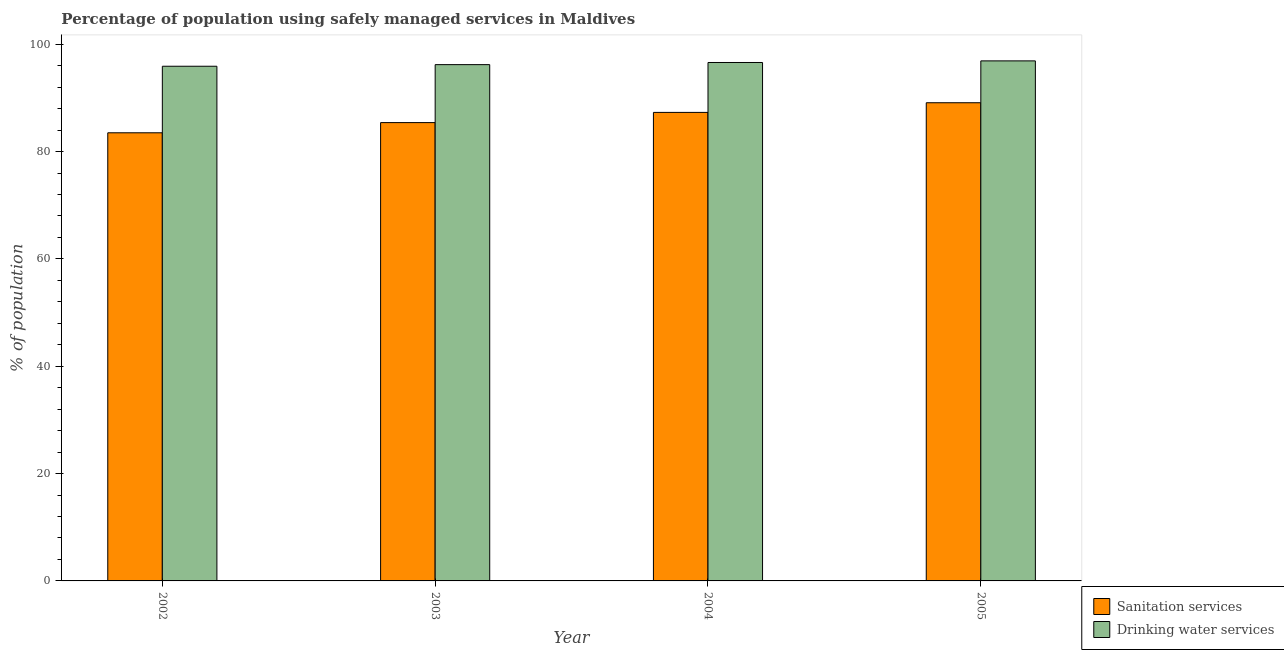How many different coloured bars are there?
Offer a very short reply. 2. Are the number of bars per tick equal to the number of legend labels?
Keep it short and to the point. Yes. Are the number of bars on each tick of the X-axis equal?
Offer a terse response. Yes. What is the label of the 2nd group of bars from the left?
Offer a very short reply. 2003. What is the percentage of population who used drinking water services in 2004?
Your response must be concise. 96.6. Across all years, what is the maximum percentage of population who used drinking water services?
Provide a succinct answer. 96.9. Across all years, what is the minimum percentage of population who used sanitation services?
Make the answer very short. 83.5. What is the total percentage of population who used drinking water services in the graph?
Make the answer very short. 385.6. What is the difference between the percentage of population who used drinking water services in 2003 and that in 2005?
Keep it short and to the point. -0.7. What is the difference between the percentage of population who used sanitation services in 2005 and the percentage of population who used drinking water services in 2002?
Keep it short and to the point. 5.6. What is the average percentage of population who used sanitation services per year?
Offer a terse response. 86.32. In the year 2005, what is the difference between the percentage of population who used sanitation services and percentage of population who used drinking water services?
Give a very brief answer. 0. In how many years, is the percentage of population who used drinking water services greater than 24 %?
Give a very brief answer. 4. What is the ratio of the percentage of population who used drinking water services in 2003 to that in 2005?
Keep it short and to the point. 0.99. Is the percentage of population who used drinking water services in 2003 less than that in 2005?
Give a very brief answer. Yes. What is the difference between the highest and the second highest percentage of population who used sanitation services?
Provide a short and direct response. 1.8. What is the difference between the highest and the lowest percentage of population who used sanitation services?
Give a very brief answer. 5.6. In how many years, is the percentage of population who used drinking water services greater than the average percentage of population who used drinking water services taken over all years?
Keep it short and to the point. 2. Is the sum of the percentage of population who used sanitation services in 2003 and 2004 greater than the maximum percentage of population who used drinking water services across all years?
Make the answer very short. Yes. What does the 1st bar from the left in 2005 represents?
Your answer should be compact. Sanitation services. What does the 2nd bar from the right in 2003 represents?
Make the answer very short. Sanitation services. Are all the bars in the graph horizontal?
Give a very brief answer. No. What is the difference between two consecutive major ticks on the Y-axis?
Provide a succinct answer. 20. What is the title of the graph?
Offer a terse response. Percentage of population using safely managed services in Maldives. Does "Travel services" appear as one of the legend labels in the graph?
Your answer should be compact. No. What is the label or title of the X-axis?
Offer a very short reply. Year. What is the label or title of the Y-axis?
Make the answer very short. % of population. What is the % of population in Sanitation services in 2002?
Your response must be concise. 83.5. What is the % of population in Drinking water services in 2002?
Provide a succinct answer. 95.9. What is the % of population in Sanitation services in 2003?
Give a very brief answer. 85.4. What is the % of population in Drinking water services in 2003?
Provide a short and direct response. 96.2. What is the % of population in Sanitation services in 2004?
Offer a terse response. 87.3. What is the % of population of Drinking water services in 2004?
Give a very brief answer. 96.6. What is the % of population of Sanitation services in 2005?
Provide a short and direct response. 89.1. What is the % of population in Drinking water services in 2005?
Give a very brief answer. 96.9. Across all years, what is the maximum % of population of Sanitation services?
Your answer should be very brief. 89.1. Across all years, what is the maximum % of population in Drinking water services?
Keep it short and to the point. 96.9. Across all years, what is the minimum % of population in Sanitation services?
Offer a very short reply. 83.5. Across all years, what is the minimum % of population in Drinking water services?
Your answer should be very brief. 95.9. What is the total % of population in Sanitation services in the graph?
Ensure brevity in your answer.  345.3. What is the total % of population in Drinking water services in the graph?
Your response must be concise. 385.6. What is the difference between the % of population of Sanitation services in 2002 and that in 2003?
Keep it short and to the point. -1.9. What is the difference between the % of population in Drinking water services in 2002 and that in 2005?
Your answer should be very brief. -1. What is the difference between the % of population in Drinking water services in 2003 and that in 2004?
Your answer should be very brief. -0.4. What is the difference between the % of population of Drinking water services in 2003 and that in 2005?
Give a very brief answer. -0.7. What is the difference between the % of population in Drinking water services in 2004 and that in 2005?
Your answer should be compact. -0.3. What is the difference between the % of population of Sanitation services in 2004 and the % of population of Drinking water services in 2005?
Your answer should be very brief. -9.6. What is the average % of population in Sanitation services per year?
Your response must be concise. 86.33. What is the average % of population in Drinking water services per year?
Provide a short and direct response. 96.4. In the year 2002, what is the difference between the % of population in Sanitation services and % of population in Drinking water services?
Your answer should be compact. -12.4. In the year 2003, what is the difference between the % of population of Sanitation services and % of population of Drinking water services?
Your answer should be compact. -10.8. In the year 2004, what is the difference between the % of population in Sanitation services and % of population in Drinking water services?
Provide a short and direct response. -9.3. In the year 2005, what is the difference between the % of population of Sanitation services and % of population of Drinking water services?
Give a very brief answer. -7.8. What is the ratio of the % of population in Sanitation services in 2002 to that in 2003?
Ensure brevity in your answer.  0.98. What is the ratio of the % of population in Drinking water services in 2002 to that in 2003?
Make the answer very short. 1. What is the ratio of the % of population in Sanitation services in 2002 to that in 2004?
Your answer should be compact. 0.96. What is the ratio of the % of population in Drinking water services in 2002 to that in 2004?
Make the answer very short. 0.99. What is the ratio of the % of population in Sanitation services in 2002 to that in 2005?
Make the answer very short. 0.94. What is the ratio of the % of population of Drinking water services in 2002 to that in 2005?
Offer a terse response. 0.99. What is the ratio of the % of population in Sanitation services in 2003 to that in 2004?
Make the answer very short. 0.98. What is the ratio of the % of population of Sanitation services in 2003 to that in 2005?
Offer a terse response. 0.96. What is the ratio of the % of population in Drinking water services in 2003 to that in 2005?
Ensure brevity in your answer.  0.99. What is the ratio of the % of population of Sanitation services in 2004 to that in 2005?
Make the answer very short. 0.98. What is the difference between the highest and the lowest % of population of Sanitation services?
Keep it short and to the point. 5.6. What is the difference between the highest and the lowest % of population of Drinking water services?
Make the answer very short. 1. 